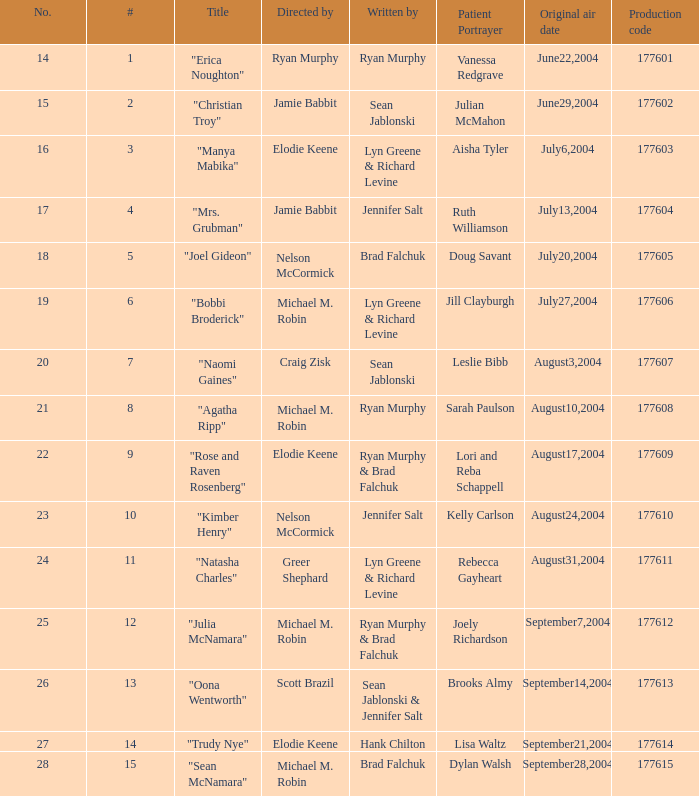What is the maximum numbered episode with patient portrayal artist doug savant? 5.0. 